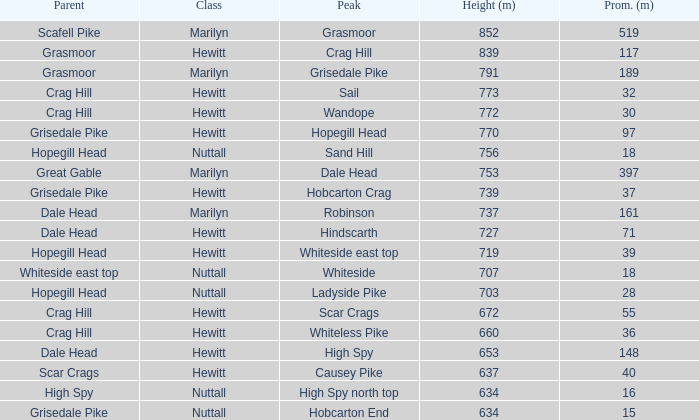What is the lowest height for Parent grasmoor when it has a Prom larger than 117? 791.0. 